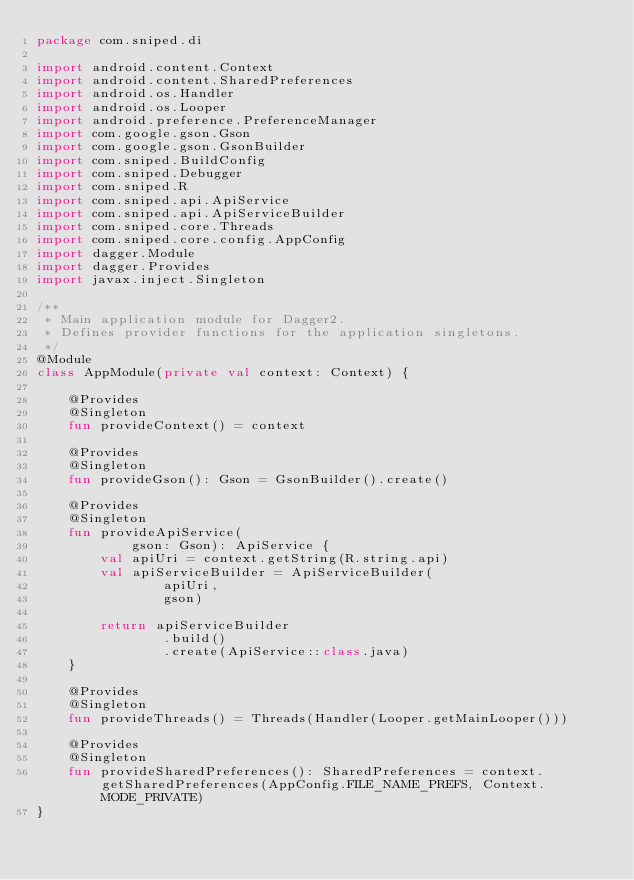<code> <loc_0><loc_0><loc_500><loc_500><_Kotlin_>package com.sniped.di

import android.content.Context
import android.content.SharedPreferences
import android.os.Handler
import android.os.Looper
import android.preference.PreferenceManager
import com.google.gson.Gson
import com.google.gson.GsonBuilder
import com.sniped.BuildConfig
import com.sniped.Debugger
import com.sniped.R
import com.sniped.api.ApiService
import com.sniped.api.ApiServiceBuilder
import com.sniped.core.Threads
import com.sniped.core.config.AppConfig
import dagger.Module
import dagger.Provides
import javax.inject.Singleton

/**
 * Main application module for Dagger2.
 * Defines provider functions for the application singletons.
 */
@Module
class AppModule(private val context: Context) {

    @Provides
    @Singleton
    fun provideContext() = context

    @Provides
    @Singleton
    fun provideGson(): Gson = GsonBuilder().create()

    @Provides
    @Singleton
    fun provideApiService(
            gson: Gson): ApiService {
        val apiUri = context.getString(R.string.api)
        val apiServiceBuilder = ApiServiceBuilder(
                apiUri,
                gson)

        return apiServiceBuilder
                .build()
                .create(ApiService::class.java)
    }

    @Provides
    @Singleton
    fun provideThreads() = Threads(Handler(Looper.getMainLooper()))

    @Provides
    @Singleton
    fun provideSharedPreferences(): SharedPreferences = context.getSharedPreferences(AppConfig.FILE_NAME_PREFS, Context.MODE_PRIVATE)
}
</code> 